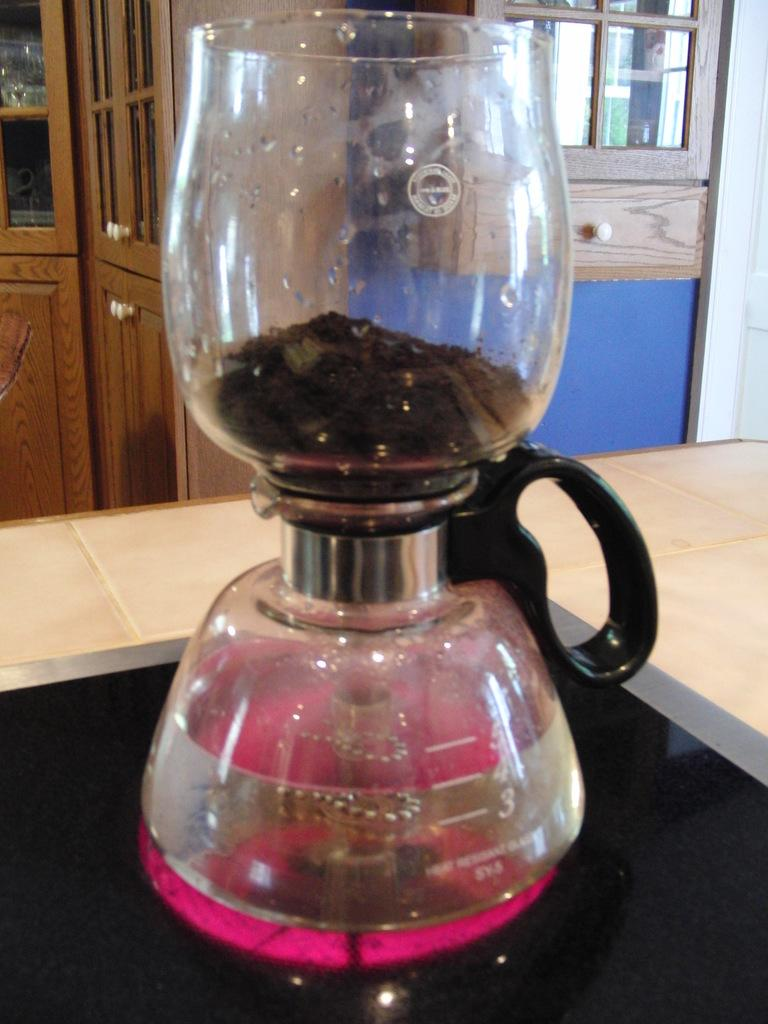<image>
Describe the image concisely. A beaker with a glass on top which is heat resistant, where there is pink liquid below the 5, 4, and 3 lines. 